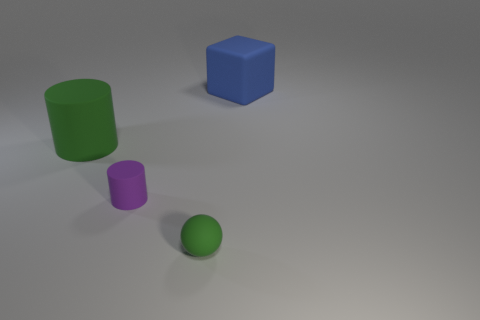Add 4 small blue rubber cylinders. How many objects exist? 8 Subtract all balls. How many objects are left? 3 Add 2 blue matte objects. How many blue matte objects are left? 3 Add 1 brown cubes. How many brown cubes exist? 1 Subtract 0 blue balls. How many objects are left? 4 Subtract all large purple cylinders. Subtract all big objects. How many objects are left? 2 